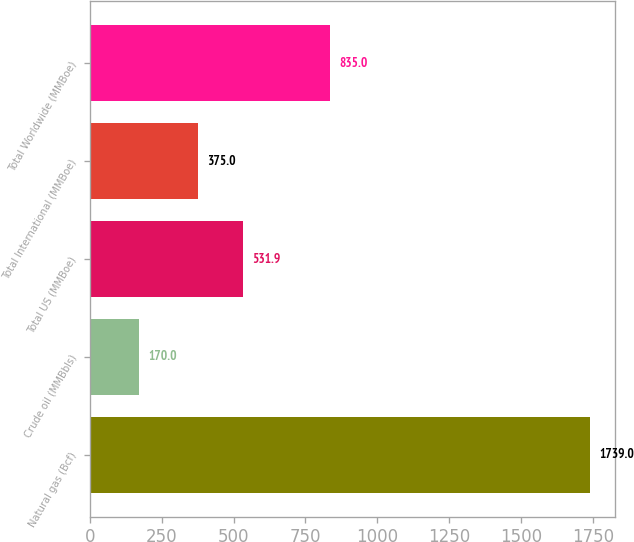Convert chart to OTSL. <chart><loc_0><loc_0><loc_500><loc_500><bar_chart><fcel>Natural gas (Bcf)<fcel>Crude oil (MMBbls)<fcel>Total US (MMBoe)<fcel>Total International (MMBoe)<fcel>Total Worldwide (MMBoe)<nl><fcel>1739<fcel>170<fcel>531.9<fcel>375<fcel>835<nl></chart> 